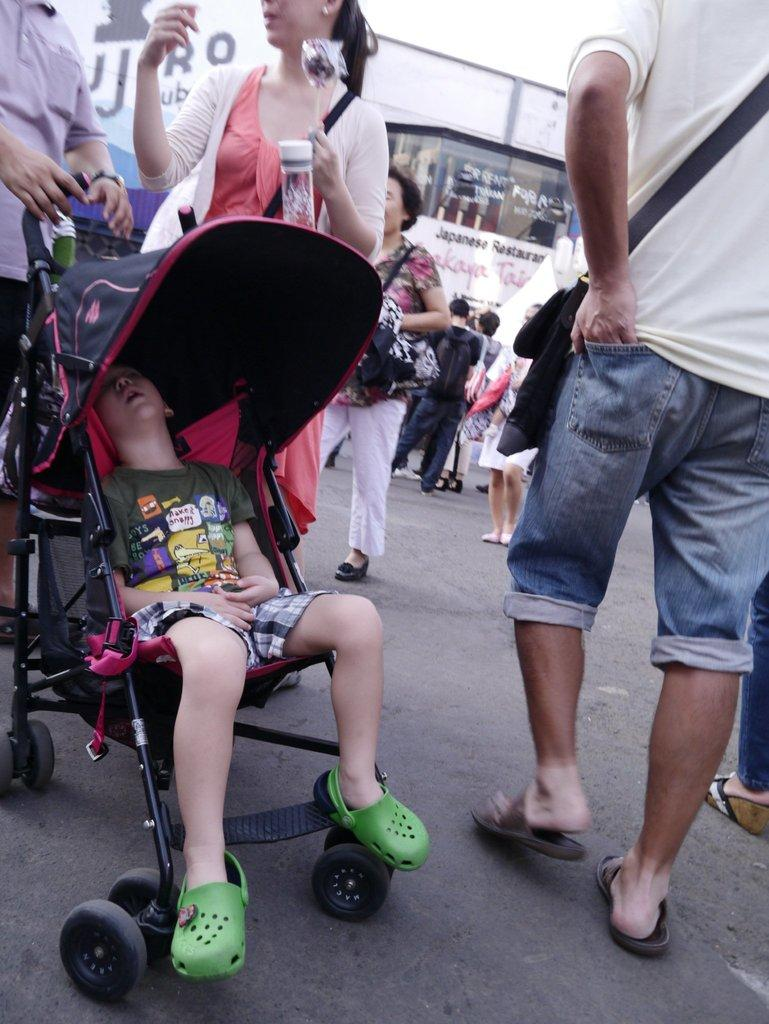What are the people in the image doing? The people in the image are walking on the road. What can be seen in the distance in the image? There is a building in the background of the image. Can you tell me how many people are swimming in the image? There is no swimming activity taking place in the image; people are walking on the road. Where is the playground located in the image? There is no playground present in the image. 